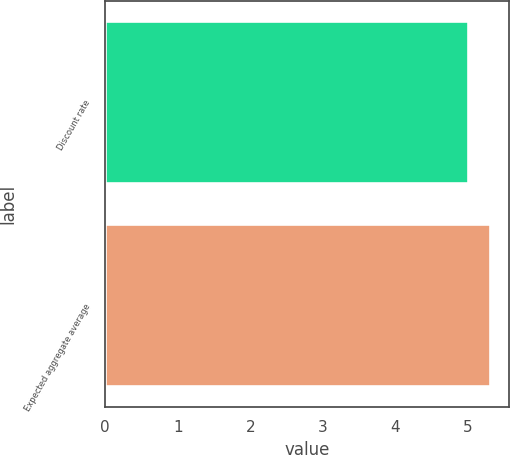Convert chart to OTSL. <chart><loc_0><loc_0><loc_500><loc_500><bar_chart><fcel>Discount rate<fcel>Expected aggregate average<nl><fcel>5<fcel>5.3<nl></chart> 